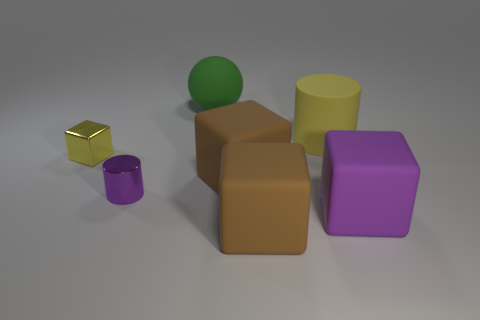What is the material of the big object that is in front of the tiny purple metal cylinder and to the left of the purple rubber cube?
Offer a terse response. Rubber. There is a cylinder left of the matte ball; is its size the same as the small metal block?
Provide a short and direct response. Yes. Is there any other thing that has the same size as the yellow metallic object?
Provide a succinct answer. Yes. Are there more purple metal things behind the small yellow block than yellow things on the left side of the large yellow rubber thing?
Keep it short and to the point. No. There is a large matte cube to the right of the yellow object that is behind the block that is left of the green object; what is its color?
Your answer should be very brief. Purple. Does the cylinder that is on the left side of the green thing have the same color as the big cylinder?
Give a very brief answer. No. How many other things are there of the same color as the large sphere?
Your response must be concise. 0. What number of things are large cubes or purple cubes?
Keep it short and to the point. 3. What number of things are brown rubber blocks or big brown rubber blocks in front of the tiny metal cylinder?
Your answer should be very brief. 2. Do the small cylinder and the large green sphere have the same material?
Make the answer very short. No. 